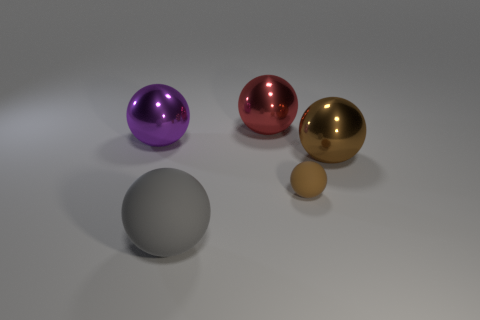Does the brown rubber thing have the same size as the rubber sphere to the left of the large red thing?
Offer a very short reply. No. Are there any brown objects that are behind the object that is left of the large sphere in front of the small brown object?
Give a very brief answer. No. There is a purple object that is the same shape as the brown shiny thing; what is its material?
Your answer should be very brief. Metal. Are there any other things that have the same material as the big gray sphere?
Your answer should be very brief. Yes. How many balls are either metal objects or purple shiny things?
Ensure brevity in your answer.  3. There is a gray object that is on the left side of the large red metallic thing; does it have the same size as the red metallic thing left of the tiny brown rubber ball?
Your answer should be compact. Yes. The brown thing that is on the right side of the brown object that is in front of the big brown object is made of what material?
Your response must be concise. Metal. Are there fewer tiny matte balls that are to the left of the tiny brown thing than brown matte spheres?
Offer a terse response. Yes. What shape is the large gray object that is made of the same material as the small brown ball?
Ensure brevity in your answer.  Sphere. How many other things are the same shape as the tiny thing?
Offer a very short reply. 4. 